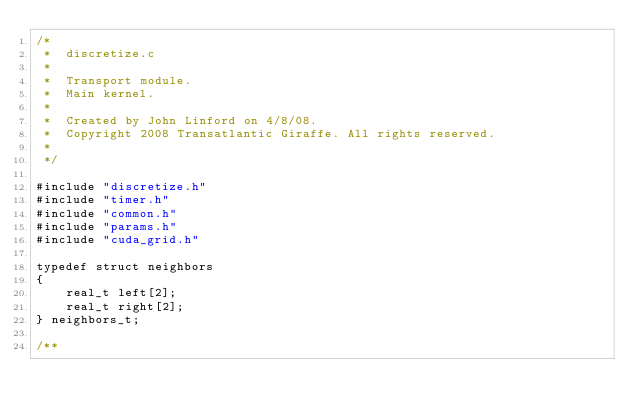<code> <loc_0><loc_0><loc_500><loc_500><_Cuda_>/*
 *  discretize.c
 *  
 *  Transport module.
 *  Main kernel.
 *
 *  Created by John Linford on 4/8/08.
 *  Copyright 2008 Transatlantic Giraffe. All rights reserved.
 *
 */

#include "discretize.h"
#include "timer.h"
#include "common.h"
#include "params.h"
#include "cuda_grid.h"

typedef struct neighbors
{
    real_t left[2];
    real_t right[2];
} neighbors_t;

/**</code> 